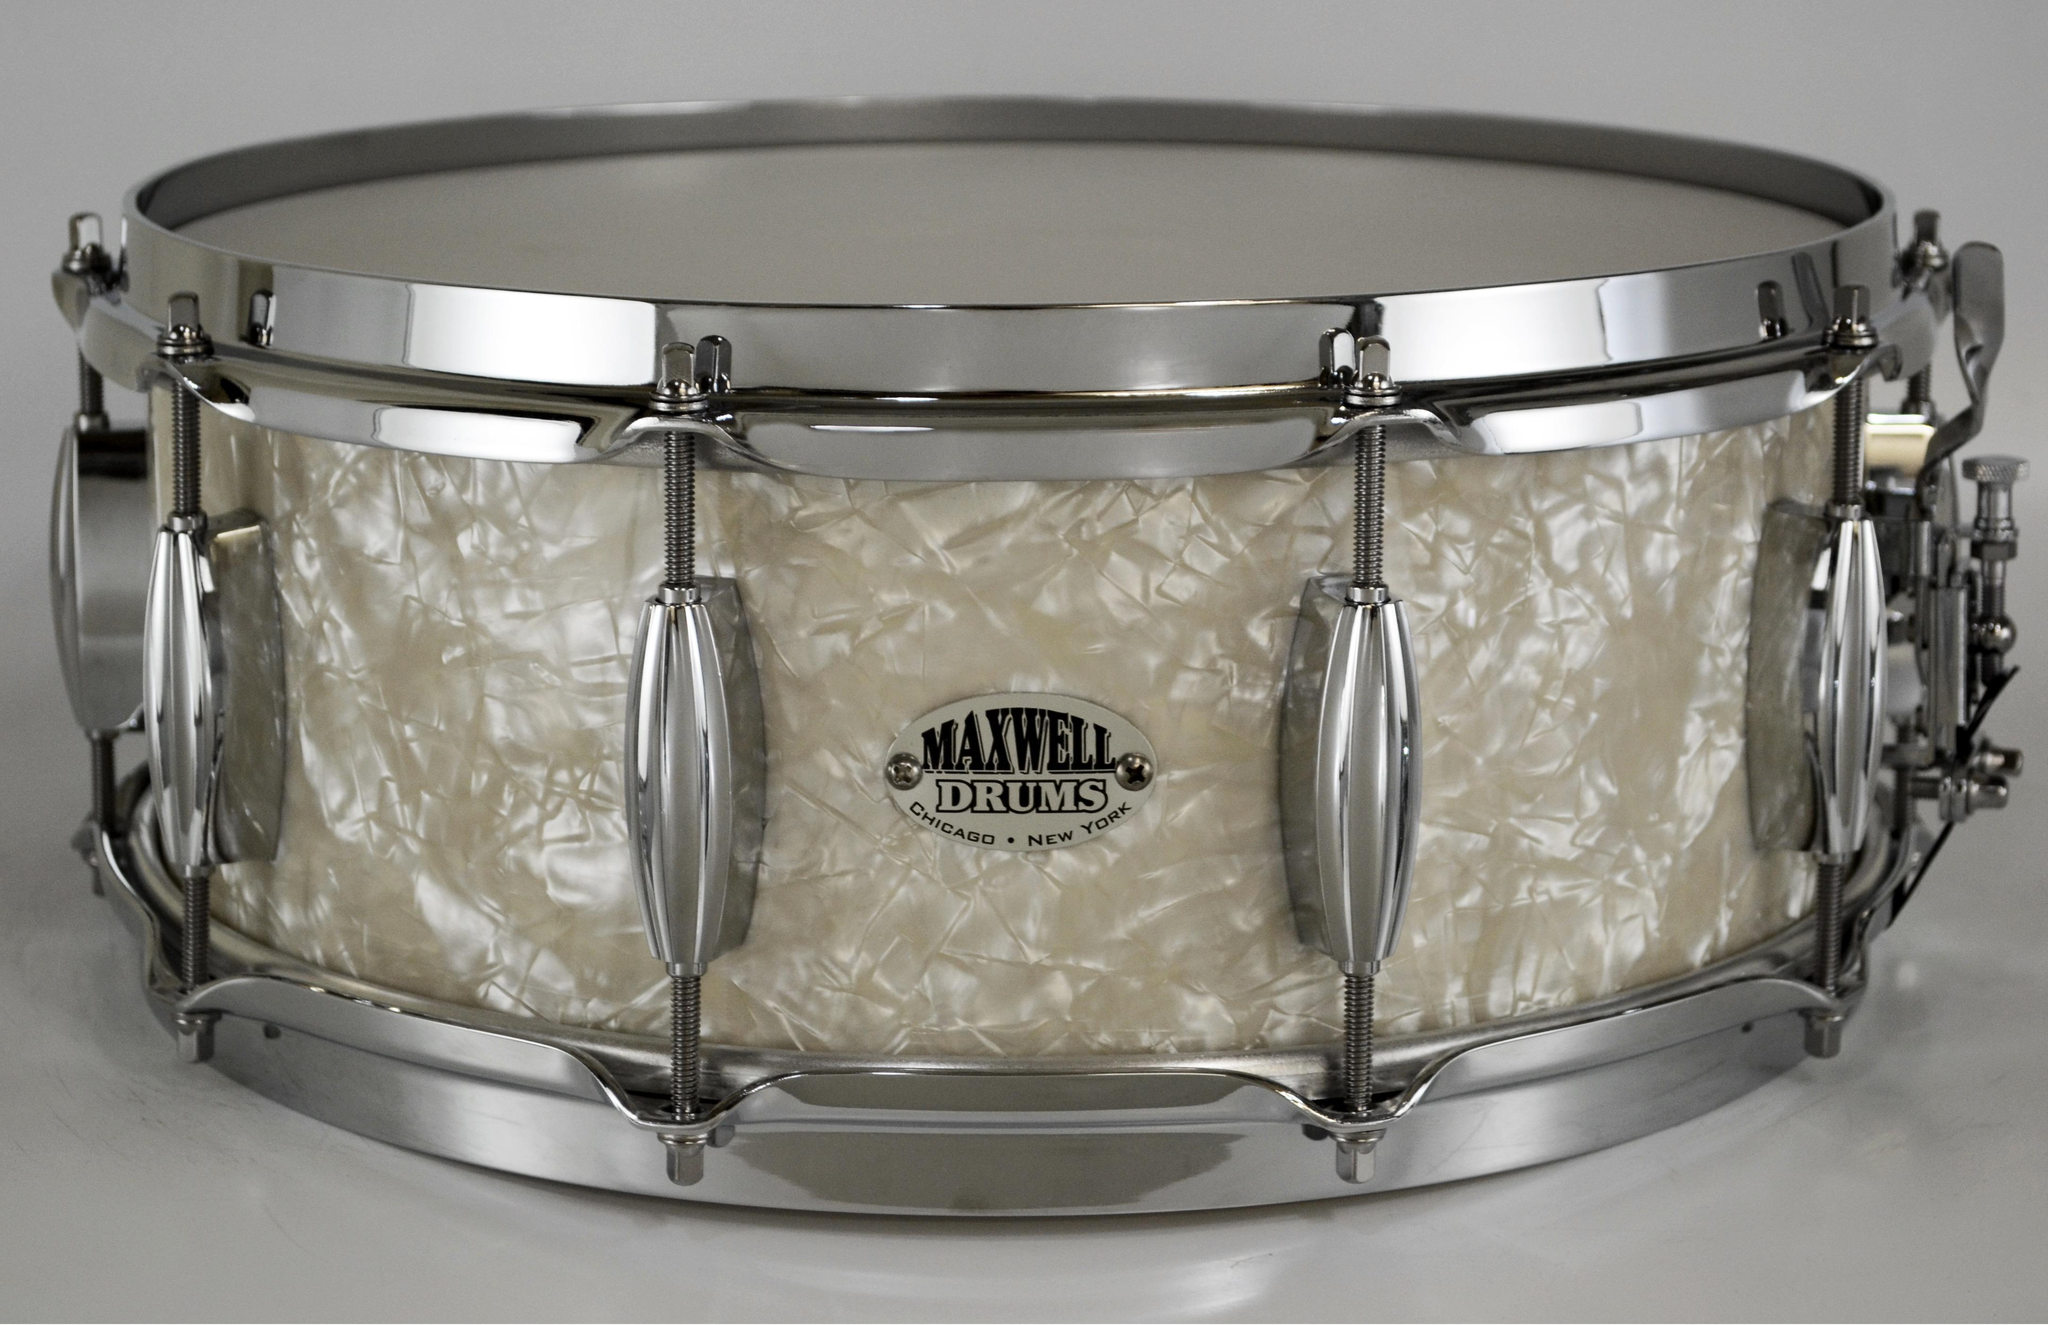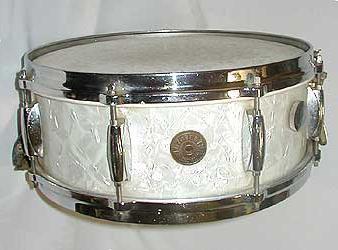The first image is the image on the left, the second image is the image on the right. For the images displayed, is the sentence "The drum on the left is white." factually correct? Answer yes or no. No. 